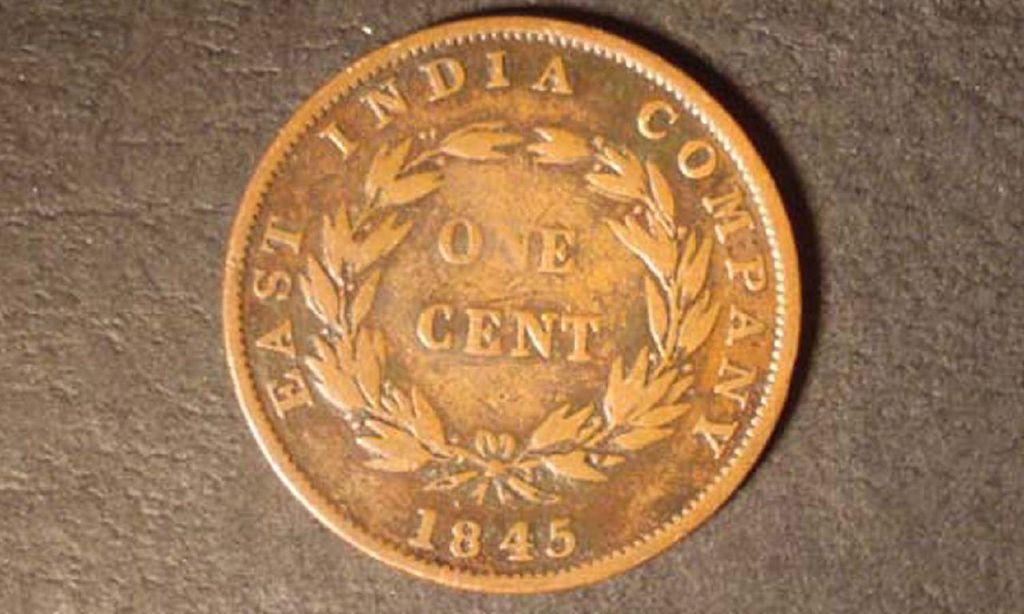What year was the coin minted?
Offer a very short reply. 1845. What is this worth?
Provide a succinct answer. One cent. 